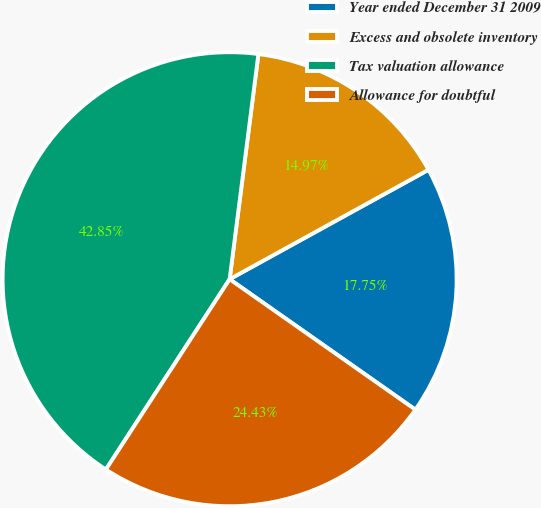Convert chart. <chart><loc_0><loc_0><loc_500><loc_500><pie_chart><fcel>Year ended December 31 2009<fcel>Excess and obsolete inventory<fcel>Tax valuation allowance<fcel>Allowance for doubtful<nl><fcel>17.75%<fcel>14.97%<fcel>42.85%<fcel>24.43%<nl></chart> 